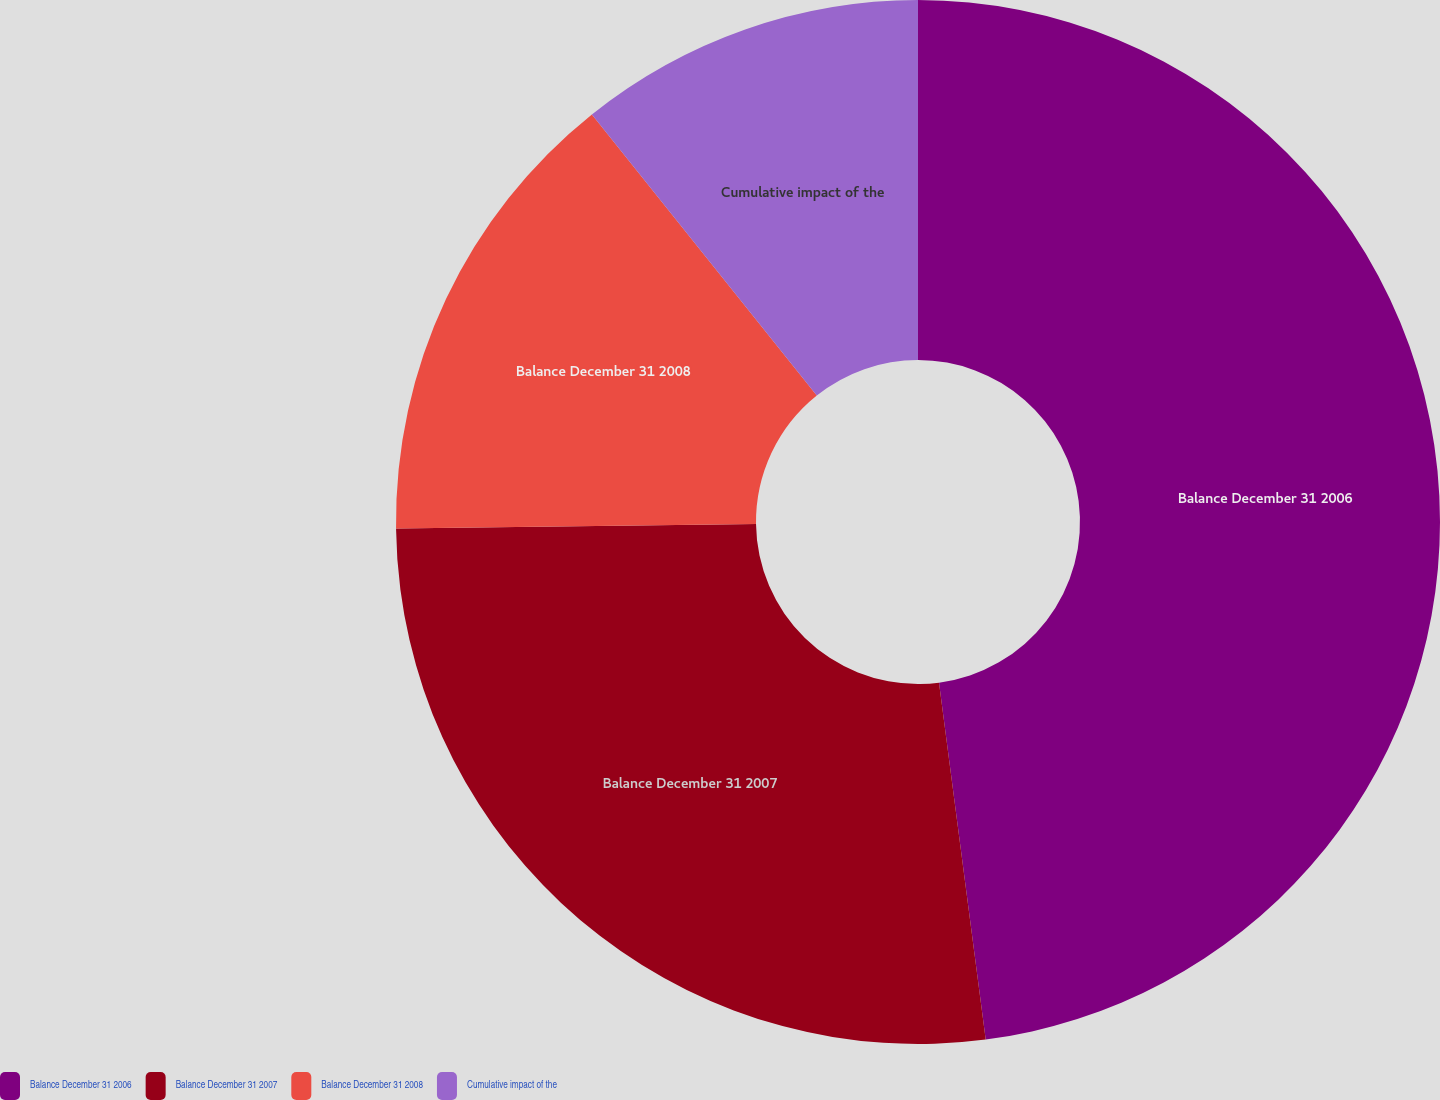Convert chart to OTSL. <chart><loc_0><loc_0><loc_500><loc_500><pie_chart><fcel>Balance December 31 2006<fcel>Balance December 31 2007<fcel>Balance December 31 2008<fcel>Cumulative impact of the<nl><fcel>47.93%<fcel>26.87%<fcel>14.46%<fcel>10.74%<nl></chart> 